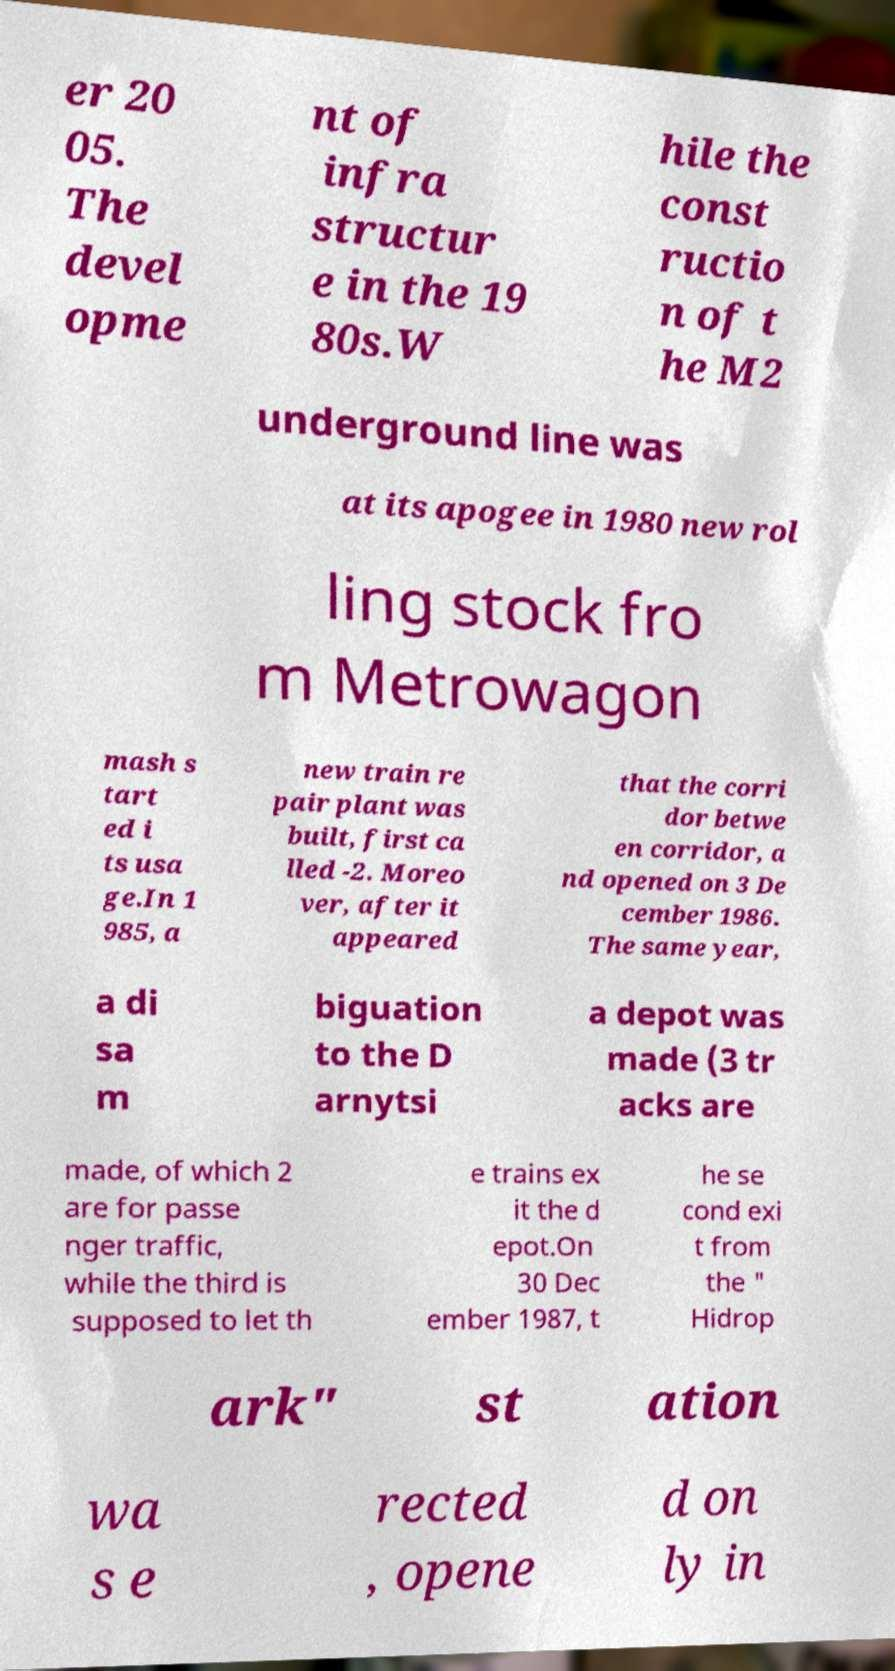There's text embedded in this image that I need extracted. Can you transcribe it verbatim? er 20 05. The devel opme nt of infra structur e in the 19 80s.W hile the const ructio n of t he M2 underground line was at its apogee in 1980 new rol ling stock fro m Metrowagon mash s tart ed i ts usa ge.In 1 985, a new train re pair plant was built, first ca lled -2. Moreo ver, after it appeared that the corri dor betwe en corridor, a nd opened on 3 De cember 1986. The same year, a di sa m biguation to the D arnytsi a depot was made (3 tr acks are made, of which 2 are for passe nger traffic, while the third is supposed to let th e trains ex it the d epot.On 30 Dec ember 1987, t he se cond exi t from the " Hidrop ark" st ation wa s e rected , opene d on ly in 